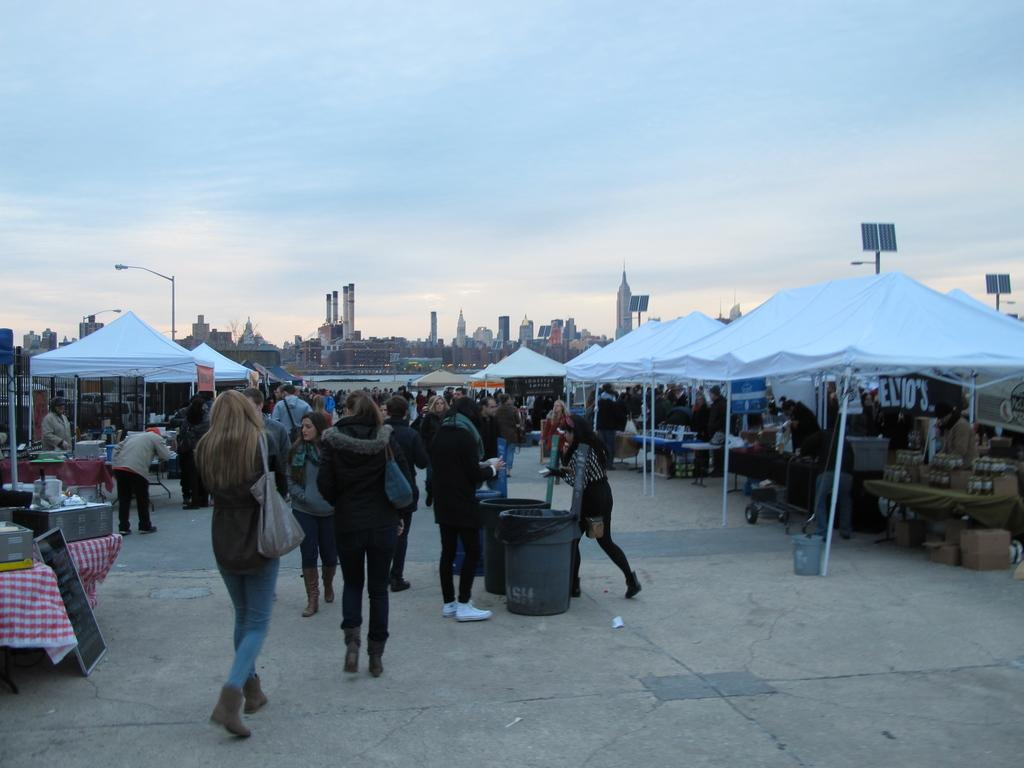What is present on both sides of the image? There are stalls on both the right and left sides of the image. What else can be seen in the image besides the stalls? There are people in the image. What can be seen in the background of the image? There are buildings and poles in the background of the image. What type of clouds can be seen in the wilderness area of the image? There is no wilderness area or clouds present in the image; it features stalls, people, buildings, and poles. 